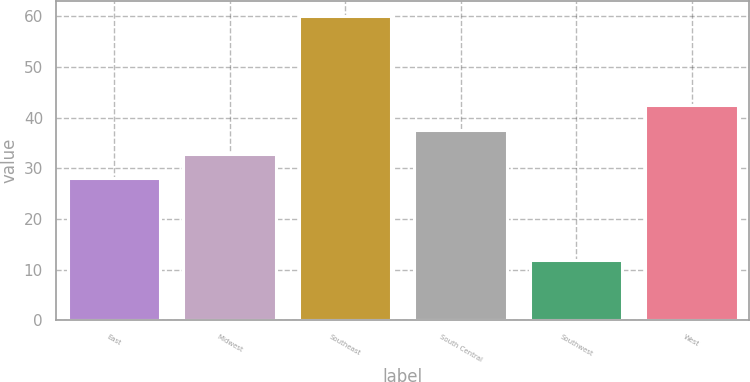Convert chart to OTSL. <chart><loc_0><loc_0><loc_500><loc_500><bar_chart><fcel>East<fcel>Midwest<fcel>Southeast<fcel>South Central<fcel>Southwest<fcel>West<nl><fcel>28<fcel>32.8<fcel>60<fcel>37.6<fcel>12<fcel>42.4<nl></chart> 